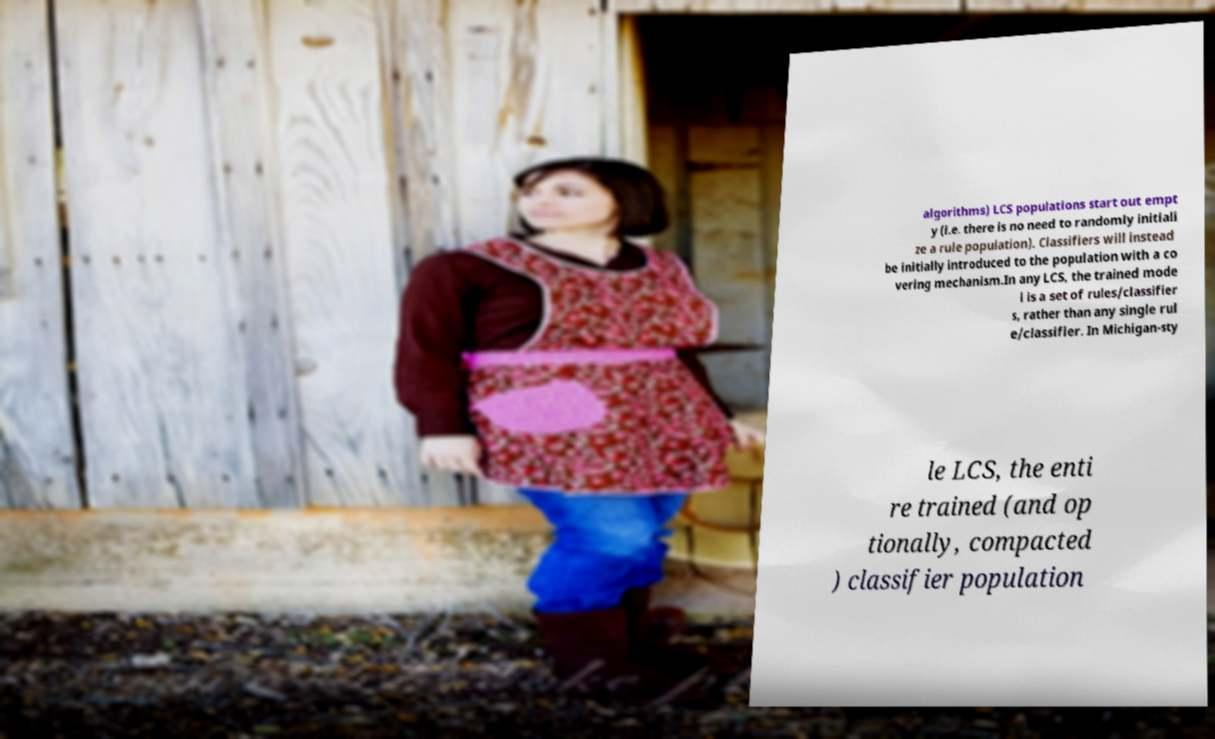What messages or text are displayed in this image? I need them in a readable, typed format. algorithms) LCS populations start out empt y (i.e. there is no need to randomly initiali ze a rule population). Classifiers will instead be initially introduced to the population with a co vering mechanism.In any LCS, the trained mode l is a set of rules/classifier s, rather than any single rul e/classifier. In Michigan-sty le LCS, the enti re trained (and op tionally, compacted ) classifier population 